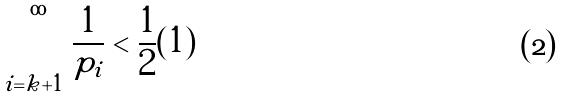<formula> <loc_0><loc_0><loc_500><loc_500>\sum _ { i = k + 1 } ^ { \infty } \frac { 1 } { p _ { i } } < \frac { 1 } { 2 } ( 1 )</formula> 